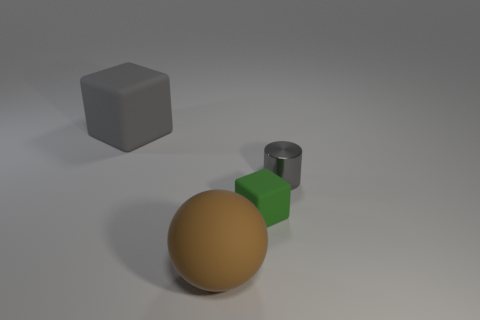Is the large block made of the same material as the green block?
Ensure brevity in your answer.  Yes. The other object that is the same color as the metal object is what size?
Provide a succinct answer. Large. Are there any small things of the same color as the big block?
Keep it short and to the point. Yes. What is the size of the gray cube that is the same material as the brown object?
Offer a very short reply. Large. What shape is the big rubber object that is behind the rubber thing that is in front of the tiny thing left of the metal object?
Your answer should be very brief. Cube. The gray matte object that is the same shape as the green object is what size?
Make the answer very short. Large. What is the size of the rubber object that is on the left side of the small green thing and in front of the metallic cylinder?
Offer a terse response. Large. What is the shape of the large matte thing that is the same color as the cylinder?
Make the answer very short. Cube. The tiny shiny thing is what color?
Your answer should be very brief. Gray. There is a rubber thing that is to the left of the sphere; what is its size?
Your answer should be very brief. Large. 